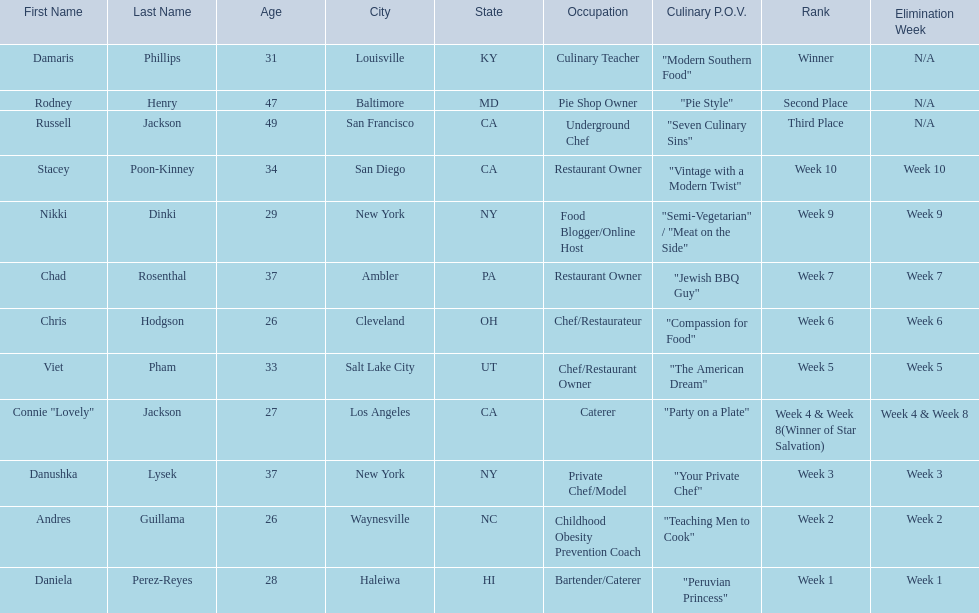Who are all of the contestants? Damaris Phillips, Rodney Henry, Russell Jackson, Stacey Poon-Kinney, Nikki Dinki, Chad Rosenthal, Chris Hodgson, Viet Pham, Connie "Lovely" Jackson, Danushka Lysek, Andres Guillama, Daniela Perez-Reyes. Which culinary p.o.v. is longer than vintage with a modern twist? "Semi-Vegetarian" / "Meat on the Side". Which contestant's p.o.v. is semi-vegetarian/meat on the side? Nikki Dinki. 